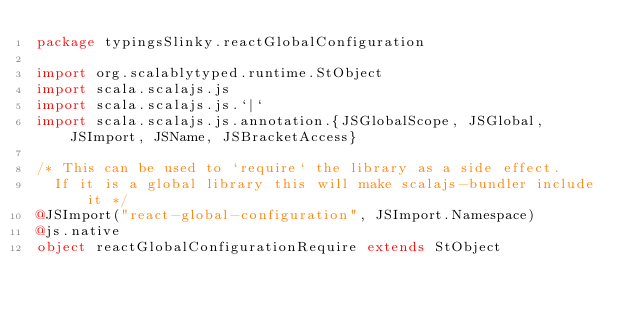Convert code to text. <code><loc_0><loc_0><loc_500><loc_500><_Scala_>package typingsSlinky.reactGlobalConfiguration

import org.scalablytyped.runtime.StObject
import scala.scalajs.js
import scala.scalajs.js.`|`
import scala.scalajs.js.annotation.{JSGlobalScope, JSGlobal, JSImport, JSName, JSBracketAccess}

/* This can be used to `require` the library as a side effect.
  If it is a global library this will make scalajs-bundler include it */
@JSImport("react-global-configuration", JSImport.Namespace)
@js.native
object reactGlobalConfigurationRequire extends StObject
</code> 